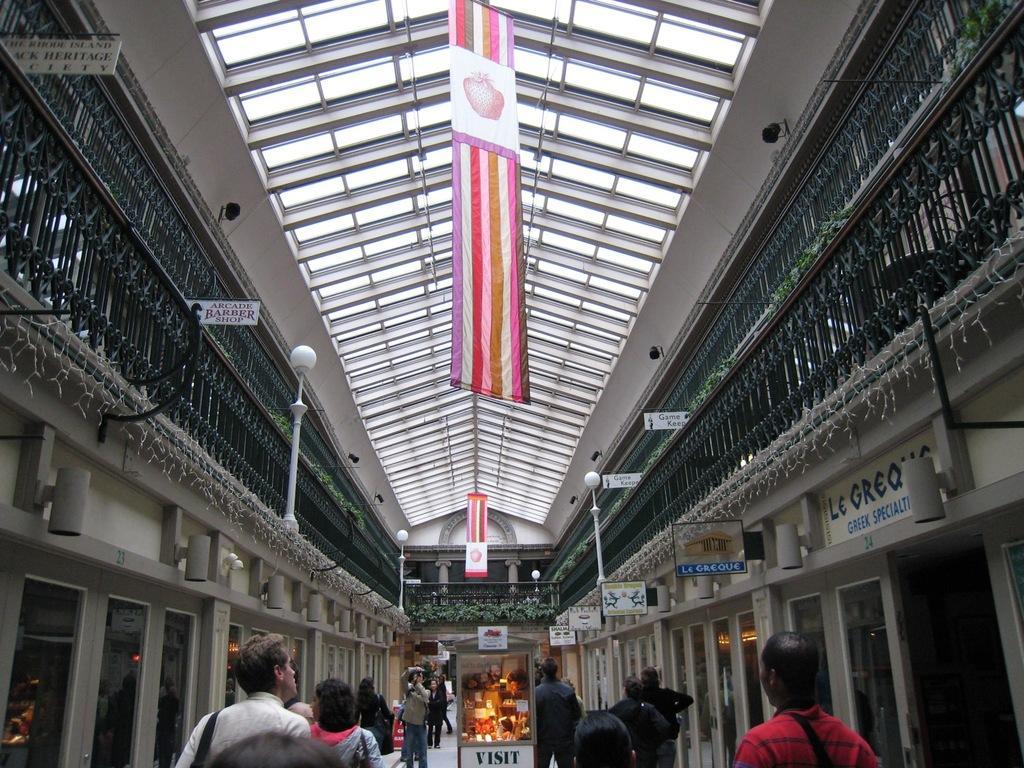Could you give a brief overview of what you see in this image? At the bottom few persons are walking, at the top it is the roof. It is an inside part of a building. 